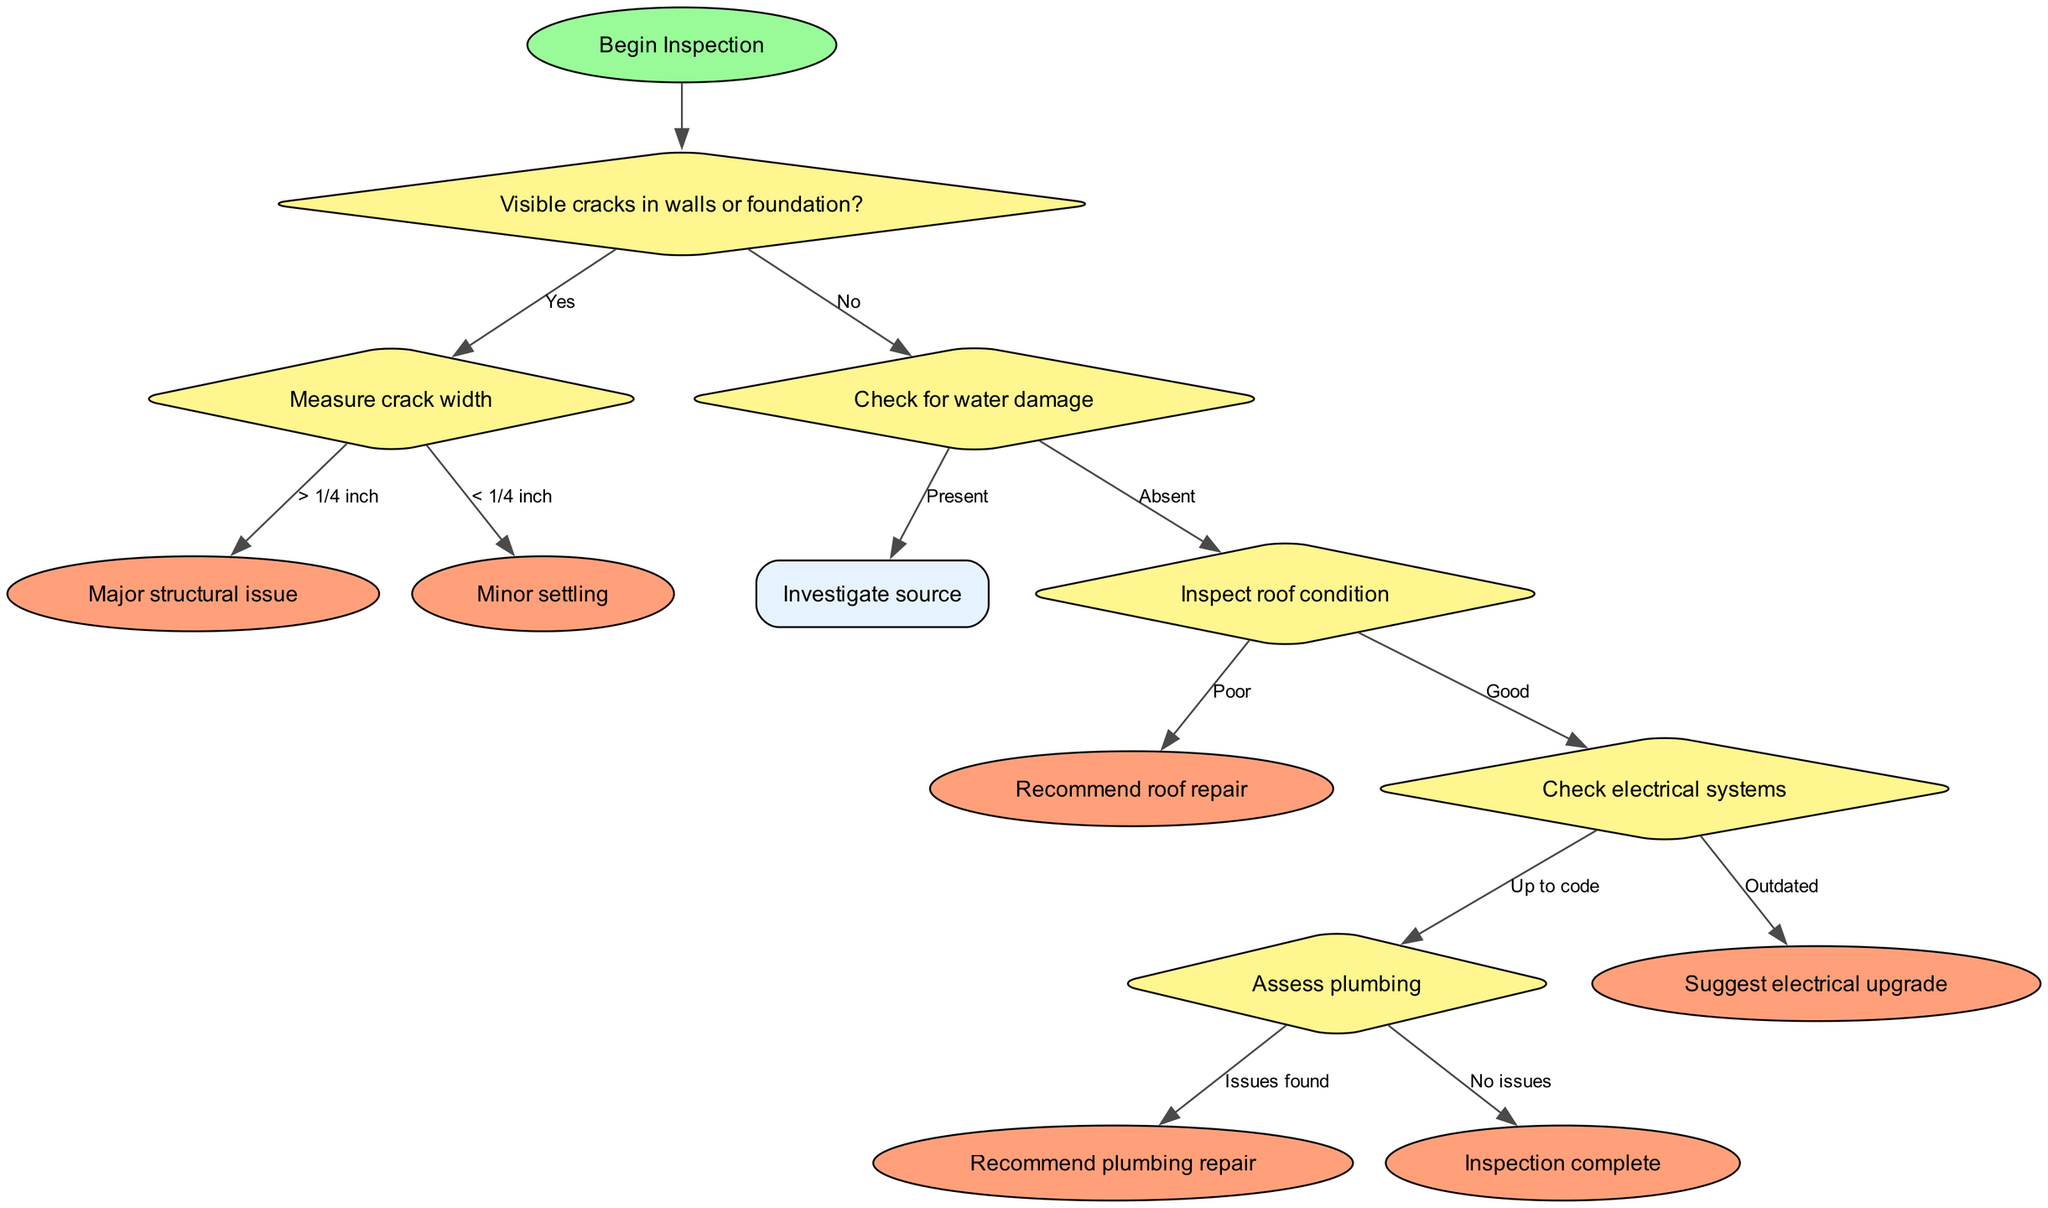What is the starting point of the flow chart? The starting point is labeled "Begin Inspection", which is the first node that indicates the commencement of the home inspection process.
Answer: Begin Inspection What step follows if there are visible cracks in walls or foundation? If visible cracks are present, the next step indicated in the flow chart is to "Measure crack width". This shows that the inspection process branches based on the presence of cracks.
Answer: Measure crack width How many end nodes are there in the diagram? By examining the flow chart, I can identify six end nodes: "Major structural issue", "Minor settling", "Recommend roof repair", "Suggest electrical upgrade", "Recommend plumbing repair", and "Inspection complete". Therefore, the total count is six.
Answer: 6 What happens after checking the electrical systems if they are outdated? If the electrical systems are outdated, the next step according to the flow chart is to "Suggest electrical upgrade". This follows the decision path where the condition of the electrical systems impacts the recommendations.
Answer: Suggest electrical upgrade If water damage is absent, what is the next step? When water damage is absent, the next step indicated is to "Inspect roof condition". This is the decision point that follows the absence of water damage, shifting focus to the roof.
Answer: Inspect roof condition What is the relationship between "Measure crack width" and "Major structural issue"? The flow chart shows that "Measure crack width" is a decision node. If the crack width is greater than 1/4 inch, it leads to the end node "Major structural issue", indicating that a major problem is present.
Answer: Major structural issue What would happen after "Investigate source" if water damage is present? Following "Investigate source" leads to additional actions that are not explicitly shown in the provided diagram since it does not specify the subsequent steps in regard to water damage investigation, making it unclear what follows in this specific iteration.
Answer: Not specified What should be recommended if plumbing issues are found? The flow chart states that if issues are found during the plumbing assessment, the next step should be to "Recommend plumbing repair", indicating the action to take based on identified problems.
Answer: Recommend plumbing repair How does one determine if the roof condition is good? The flow chart indicates that after inspecting the roof, if the condition is marked as "Good", the flow will then move to "Check electrical systems", showing the pathway dependent on the roof’s state.
Answer: Check electrical systems 